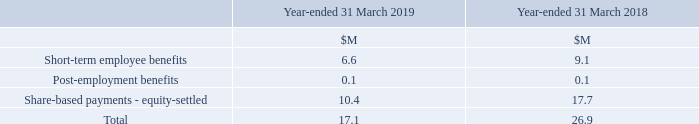Compensation of Key Management Personnel (Including Directors)
Short-term employee benefits comprise fees, salaries, benefits and bonuses earned during the year as well as nonmonetary benefits.
Post-employment benefits comprise the cost of providing defined contribution pensions to senior management in respect of the current period.
Share-based payments comprise the cost of senior management’s participation in share-based payment plans for the period as measured by the fair value of awards in accordance with IFRS2.
What do short-term employee benefits comprise? Fees, salaries, benefits and bonuses earned during the year as well as nonmonetary benefits. What do post-employment benefits comprise? The cost of providing defined contribution pensions to senior management in respect of the current period. What are the components making up the total Compensation of Key Management Personnel in the table? Short-term employee benefits, post-employment benefits, share-based payments - equity-settled. In which year was the Total compensation of key management personnel larger? 26.9>17.1
Answer: 2018. What was the change in the Total compensation of key management personnel  in 2019 from 2018?
Answer scale should be: million. 17.1-26.9
Answer: -9.8. What was the percentage change in the Total compensation of key management personnel  in 2019 from 2018?
Answer scale should be: percent. (17.1-26.9)/26.9
Answer: -36.43. 